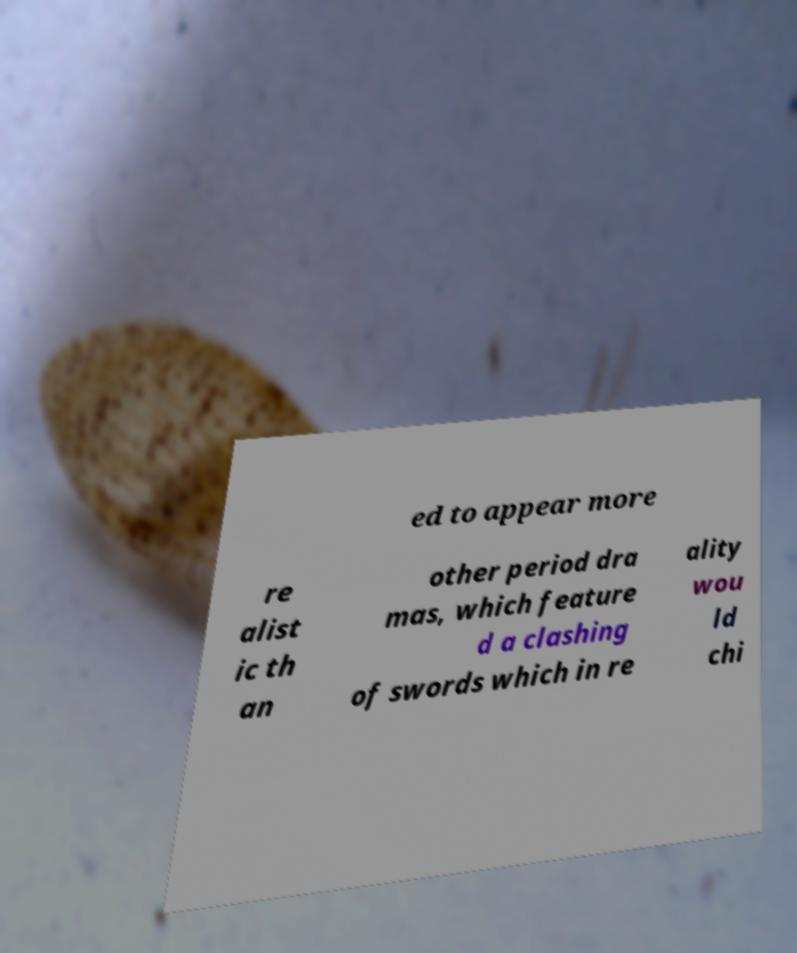I need the written content from this picture converted into text. Can you do that? ed to appear more re alist ic th an other period dra mas, which feature d a clashing of swords which in re ality wou ld chi 